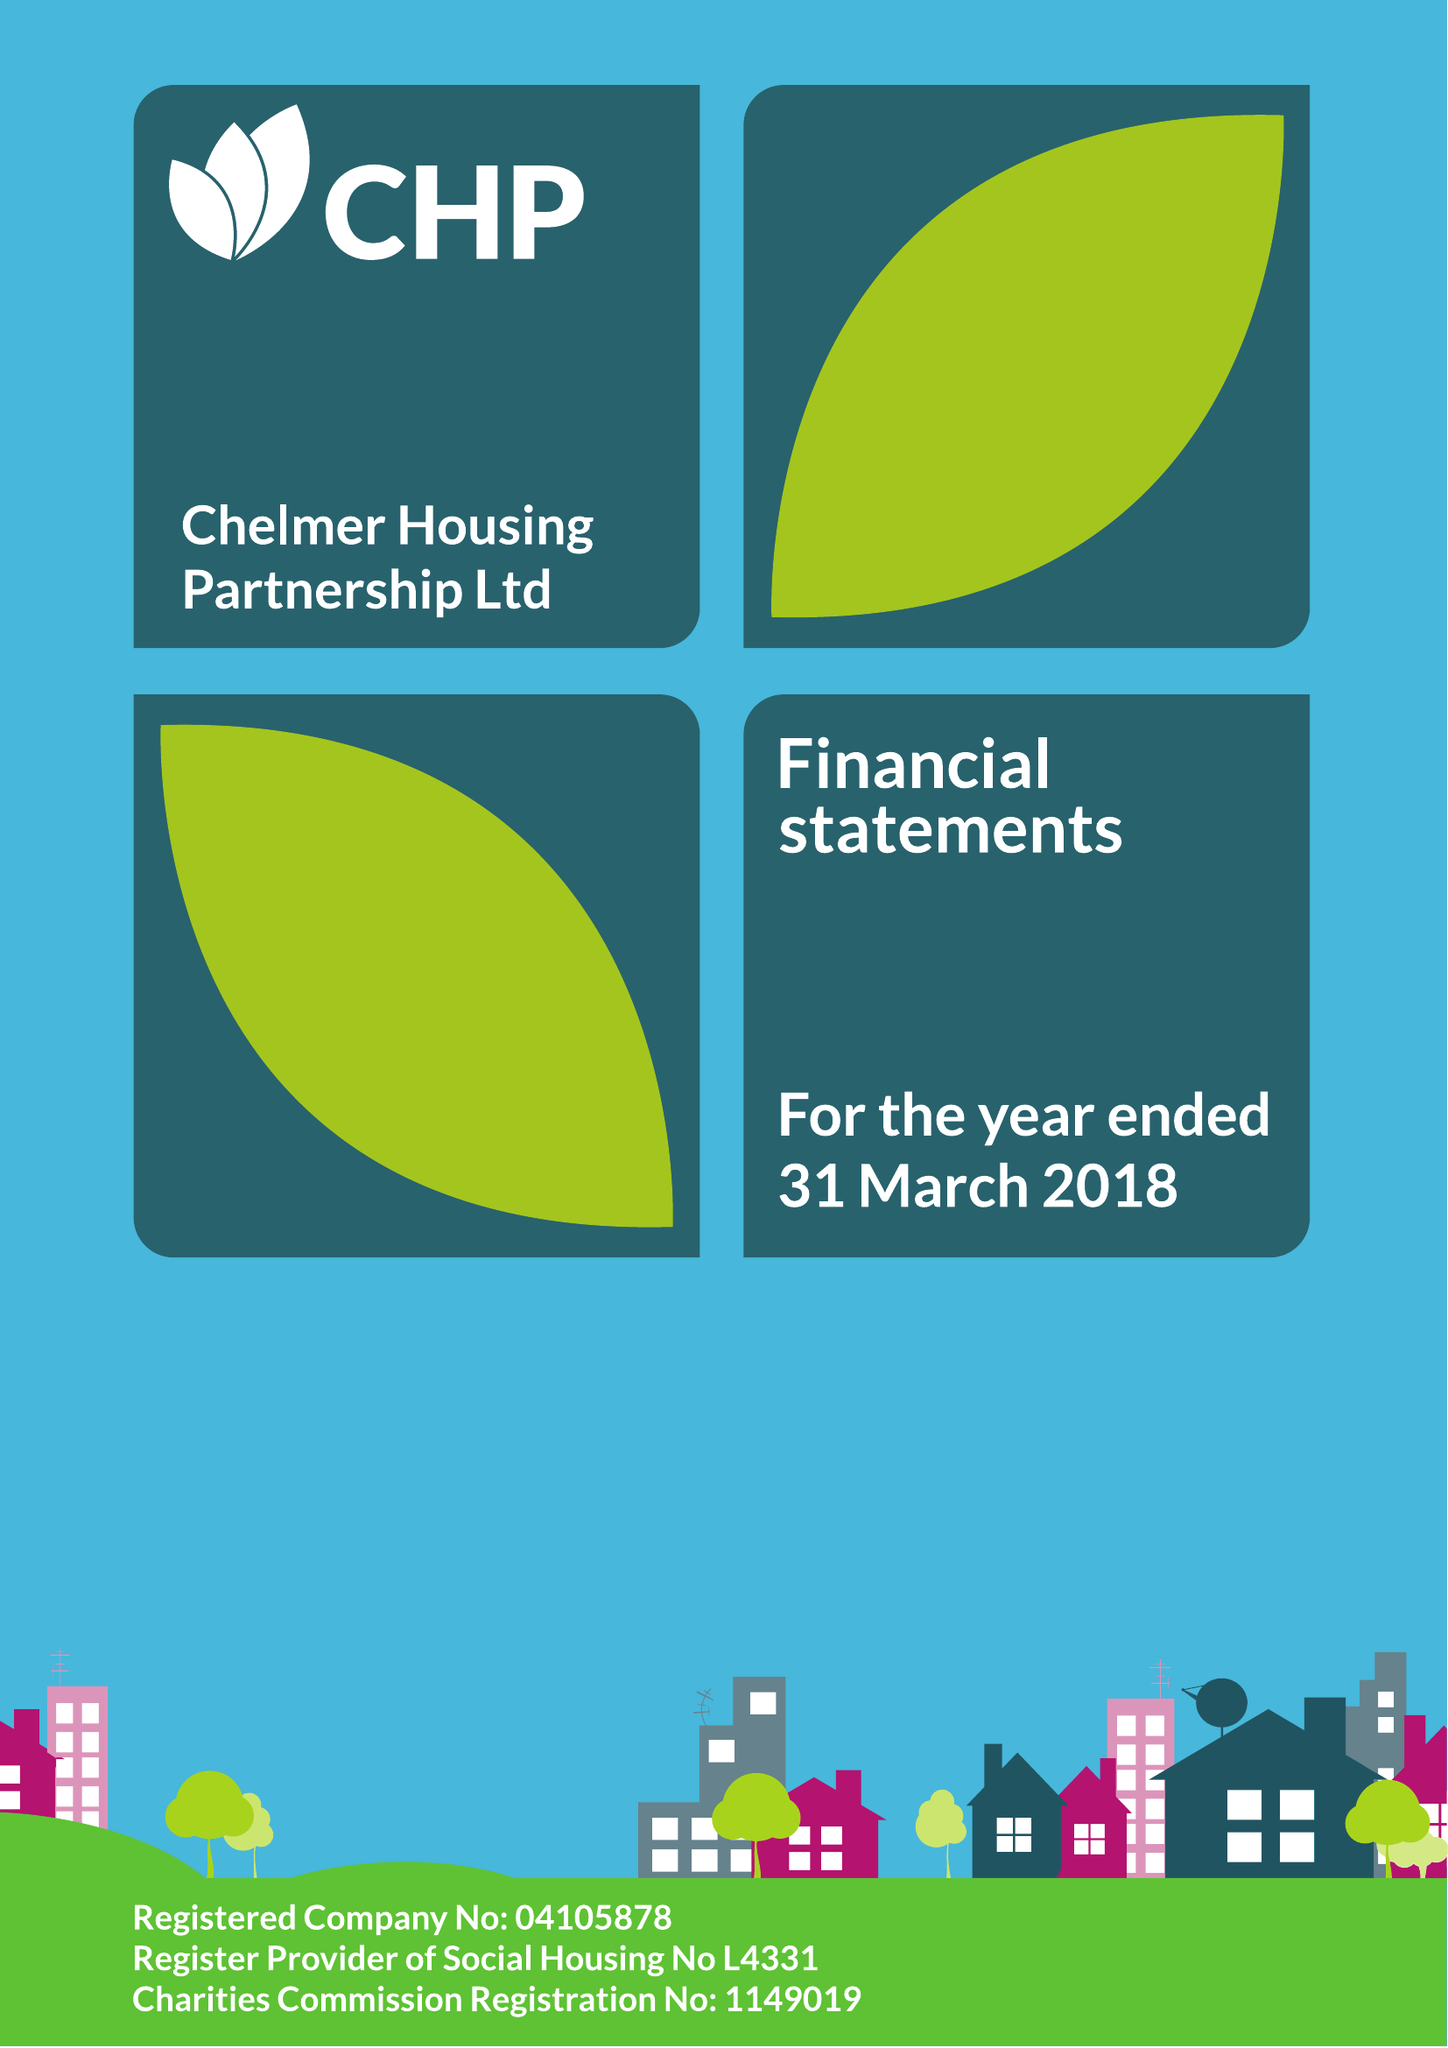What is the value for the address__street_line?
Answer the question using a single word or phrase. None 